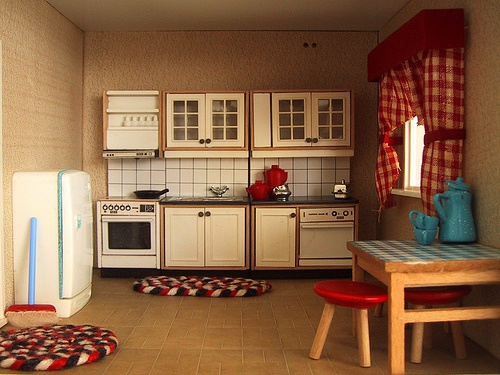Describe the objects in this image and their specific colors. I can see dining table in tan, orange, maroon, black, and brown tones, refrigerator in tan, beige, and darkgray tones, oven in tan and black tones, chair in tan, maroon, and brown tones, and chair in tan, maroon, black, brown, and gray tones in this image. 